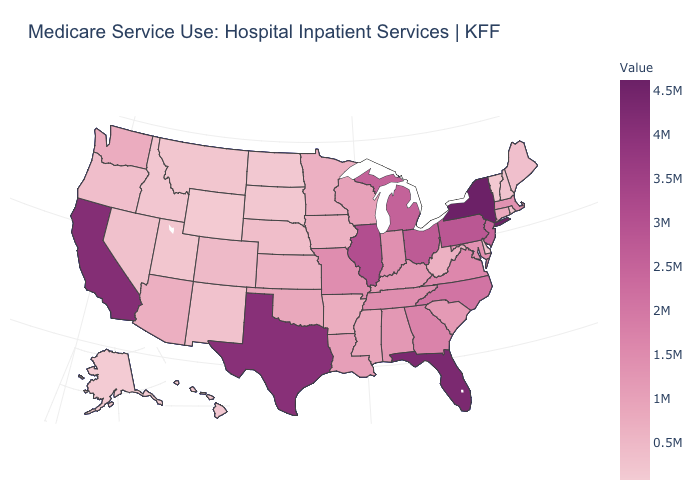Does New Jersey have the lowest value in the USA?
Quick response, please. No. Which states have the highest value in the USA?
Quick response, please. New York. Is the legend a continuous bar?
Answer briefly. Yes. Does Illinois have the highest value in the MidWest?
Keep it brief. Yes. Does Texas have a lower value than New York?
Quick response, please. Yes. Among the states that border Utah , does Arizona have the highest value?
Short answer required. Yes. Among the states that border New Mexico , which have the lowest value?
Give a very brief answer. Utah. 